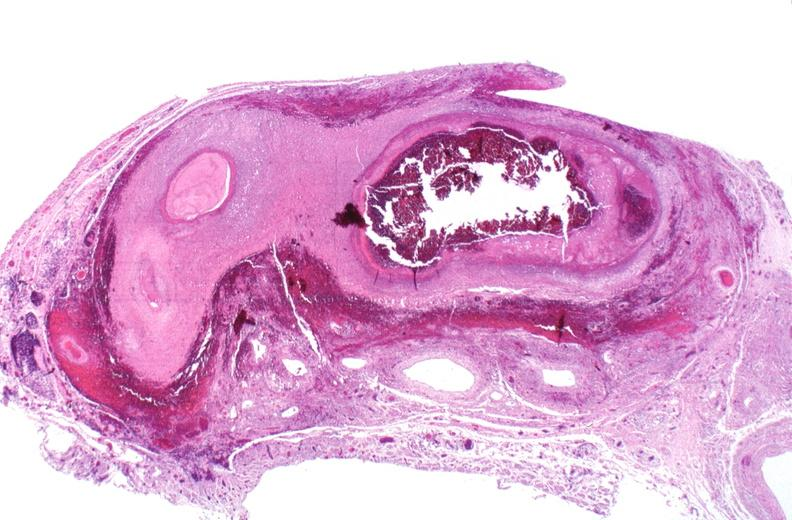s vasculature present?
Answer the question using a single word or phrase. Yes 